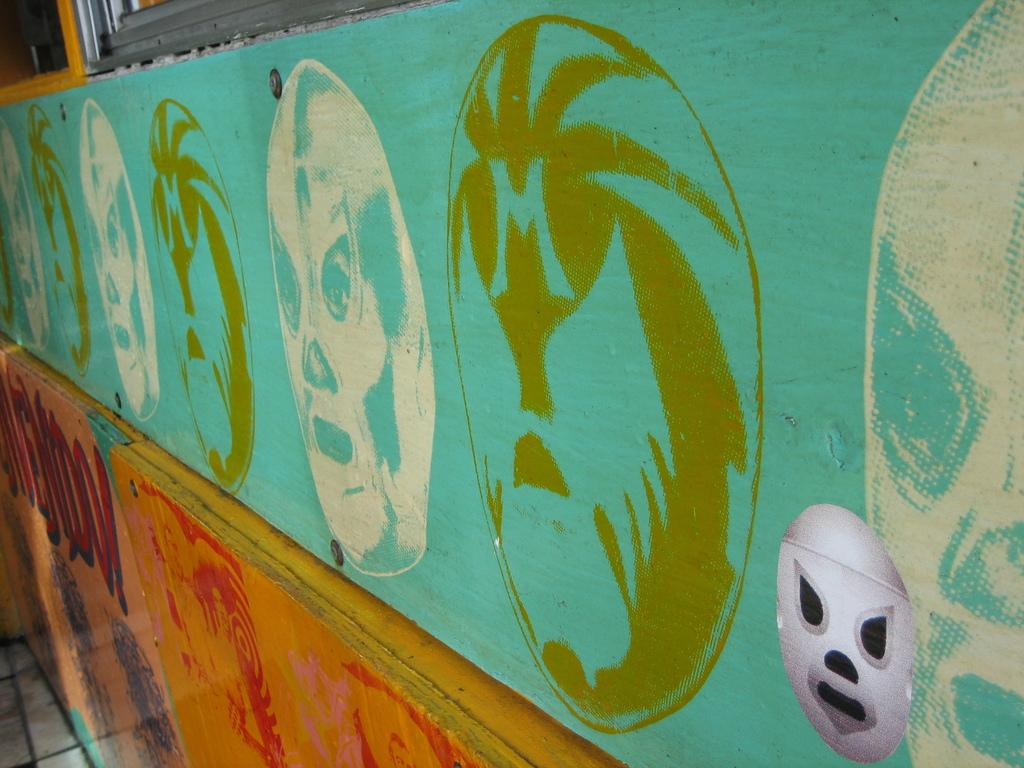What is present on the wall in the image? There is a painting on the wall in the image. What colors are used in the painting? The painting has blue and yellow colors. How is the painting positioned in the image? The painting is placed on the floor. What is the floor made of in the image? The floor has tiles. Can you see any goldfish swimming in the painting? There are no goldfish present in the painting; it features blue and yellow colors. What type of wing is depicted in the painting? There is no wing depicted in the painting; it only features blue and yellow colors. 